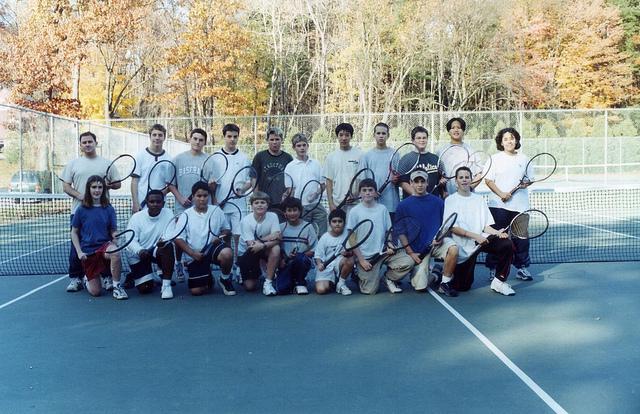What sport are they equipped for?
Quick response, please. Tennis. How many people are not wearing white?
Be succinct. 4. Was this image taken in the fall?
Keep it brief. Yes. 